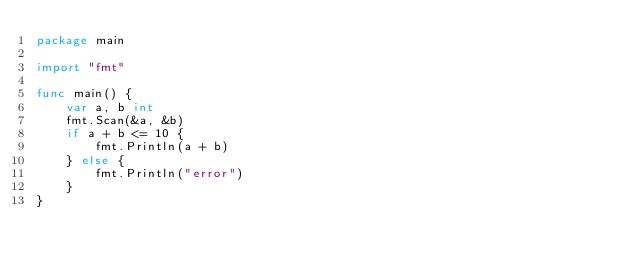Convert code to text. <code><loc_0><loc_0><loc_500><loc_500><_Go_>package main

import "fmt"

func main() {
	var a, b int
	fmt.Scan(&a, &b)
	if a + b <= 10 {
		fmt.Println(a + b)
	} else {
		fmt.Println("error")
	}
}
</code> 